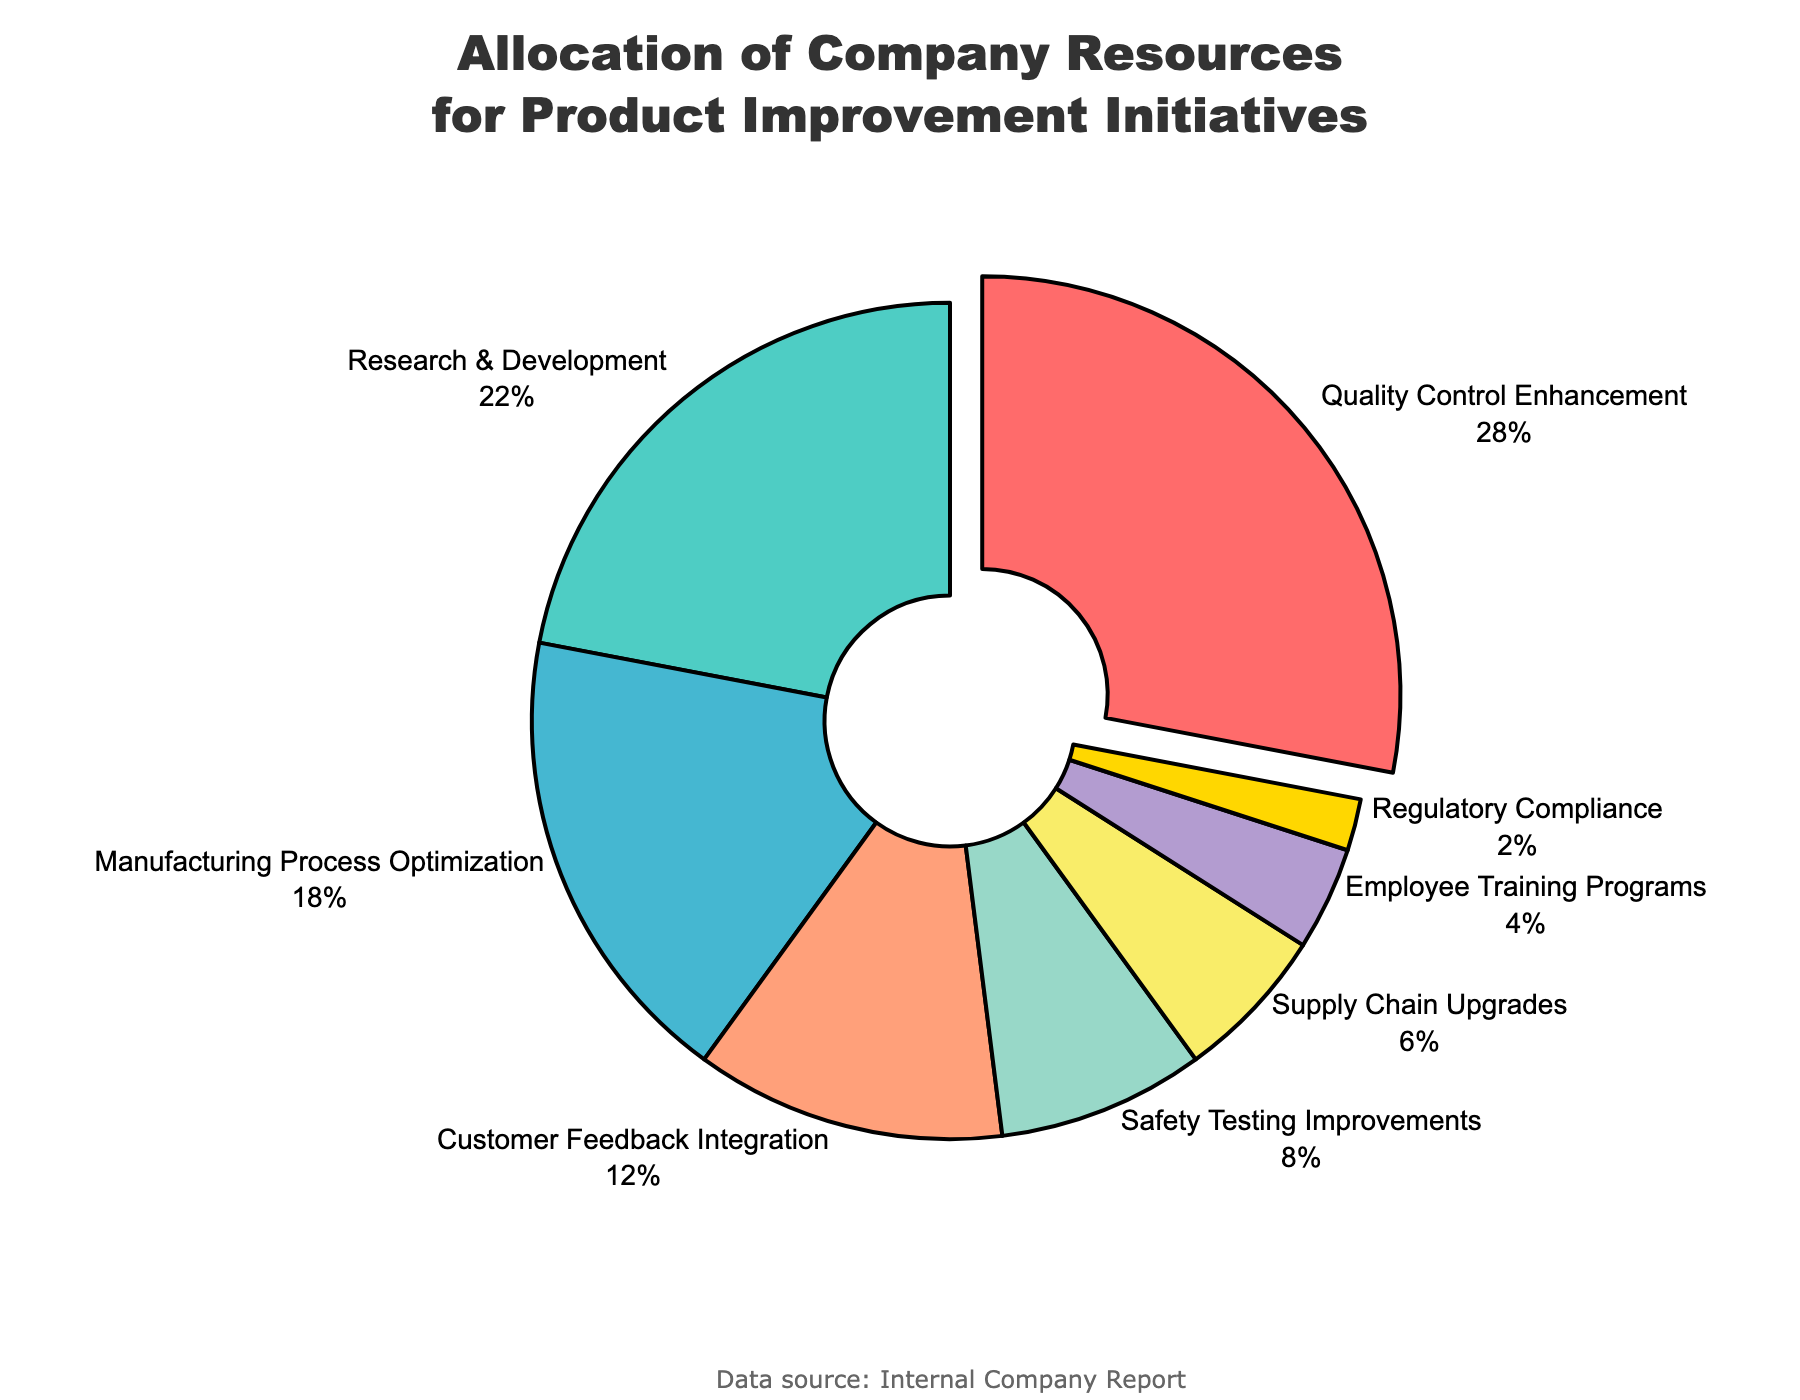What percentage of resources is allocated to enhancing quality control? The chart labels denote that 28% of the resources are allocated to Quality Control Enhancement.
Answer: 28% Which initiative receives the least amount of resources? The category "Regulatory Compliance" shows the smallest portion of the pie chart at 2%.
Answer: Regulatory Compliance How much more percentage is allocated to Research & Development compared to Supply Chain Upgrades? Research & Development is allocated 22%, and Supply Chain Upgrades is allocated 6%. The difference is 22% - 6% = 16%.
Answer: 16% Do Customer Feedback Integration and Safety Testing Improvements combined receive more resources than Manufacturing Process Optimization? Customer Feedback Integration is allocated 12% and Safety Testing Improvements 8%. Combined, they amount to 20%. Manufacturing Process Optimization is allocated 18%. Since 20% > 18%, the combined resources are more.
Answer: Yes How many categories receive less than 10% of resources? By examining the chart, we see that Safety Testing Improvements, Supply Chain Upgrades, Employee Training Programs, and Regulatory Compliance each receive less than 10%. That makes 4 categories.
Answer: 4 What is the total percentage of resources allocated to categories listed in blue and green colors? The blue portion represents Manufacturing Process Optimization (18%) and the green portion represents Research & Development (22%). Summing them yields 18% + 22% = 40%.
Answer: 40% Which initiative receives double the allocation of Employee Training Programs, and how much is it? Employee Training Programs receive 4%. Double that is 4% * 2 = 8%. Safety Testing Improvements receive exactly 8%.
Answer: Safety Testing Improvements, 8% Among the allocations, which is the second highest and what is its percentage? The highest allocation is for Quality Control Enhancement (28%). The second highest is Research & Development (22%).
Answer: Research & Development, 22% What is the total percentage of resources allocated to the top three initiatives? The top three categories are Quality Control Enhancement (28%), Research & Development (22%), and Manufacturing Process Optimization (18%). Summing these gives 28% + 22% + 18% = 68%.
Answer: 68% 